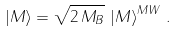<formula> <loc_0><loc_0><loc_500><loc_500>\left | M \right > = \sqrt { 2 \, M _ { B } } \, \left | M \right > ^ { M W } \, .</formula> 